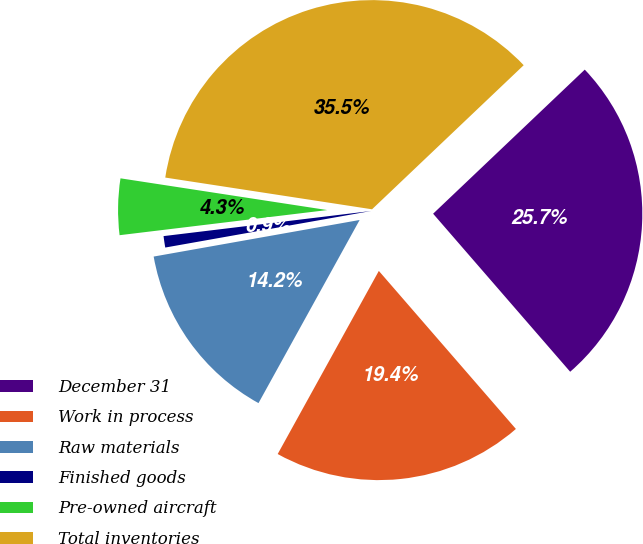Convert chart. <chart><loc_0><loc_0><loc_500><loc_500><pie_chart><fcel>December 31<fcel>Work in process<fcel>Raw materials<fcel>Finished goods<fcel>Pre-owned aircraft<fcel>Total inventories<nl><fcel>25.72%<fcel>19.4%<fcel>14.17%<fcel>0.88%<fcel>4.34%<fcel>35.48%<nl></chart> 